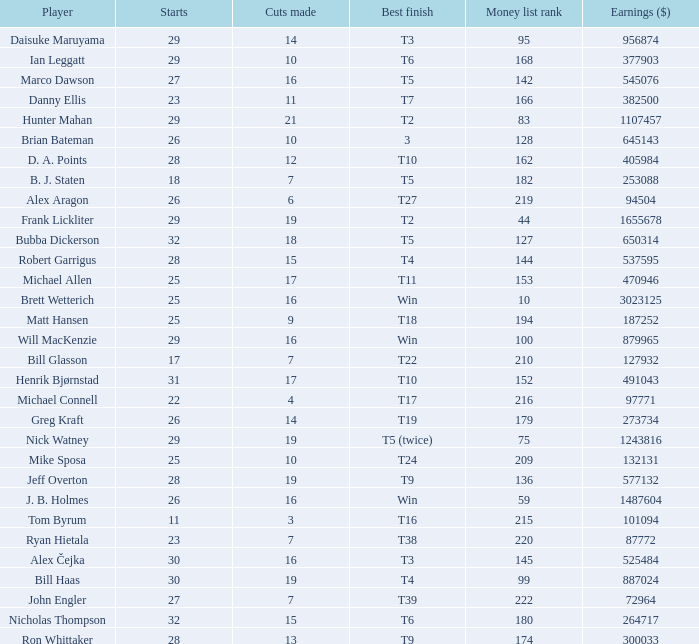What is the minimum number of starts for the players having a best finish of T18? 25.0. Would you be able to parse every entry in this table? {'header': ['Player', 'Starts', 'Cuts made', 'Best finish', 'Money list rank', 'Earnings ($)'], 'rows': [['Daisuke Maruyama', '29', '14', 'T3', '95', '956874'], ['Ian Leggatt', '29', '10', 'T6', '168', '377903'], ['Marco Dawson', '27', '16', 'T5', '142', '545076'], ['Danny Ellis', '23', '11', 'T7', '166', '382500'], ['Hunter Mahan', '29', '21', 'T2', '83', '1107457'], ['Brian Bateman', '26', '10', '3', '128', '645143'], ['D. A. Points', '28', '12', 'T10', '162', '405984'], ['B. J. Staten', '18', '7', 'T5', '182', '253088'], ['Alex Aragon', '26', '6', 'T27', '219', '94504'], ['Frank Lickliter', '29', '19', 'T2', '44', '1655678'], ['Bubba Dickerson', '32', '18', 'T5', '127', '650314'], ['Robert Garrigus', '28', '15', 'T4', '144', '537595'], ['Michael Allen', '25', '17', 'T11', '153', '470946'], ['Brett Wetterich', '25', '16', 'Win', '10', '3023125'], ['Matt Hansen', '25', '9', 'T18', '194', '187252'], ['Will MacKenzie', '29', '16', 'Win', '100', '879965'], ['Bill Glasson', '17', '7', 'T22', '210', '127932'], ['Henrik Bjørnstad', '31', '17', 'T10', '152', '491043'], ['Michael Connell', '22', '4', 'T17', '216', '97771'], ['Greg Kraft', '26', '14', 'T19', '179', '273734'], ['Nick Watney', '29', '19', 'T5 (twice)', '75', '1243816'], ['Mike Sposa', '25', '10', 'T24', '209', '132131'], ['Jeff Overton', '28', '19', 'T9', '136', '577132'], ['J. B. Holmes', '26', '16', 'Win', '59', '1487604'], ['Tom Byrum', '11', '3', 'T16', '215', '101094'], ['Ryan Hietala', '23', '7', 'T38', '220', '87772'], ['Alex Čejka', '30', '16', 'T3', '145', '525484'], ['Bill Haas', '30', '19', 'T4', '99', '887024'], ['John Engler', '27', '7', 'T39', '222', '72964'], ['Nicholas Thompson', '32', '15', 'T6', '180', '264717'], ['Ron Whittaker', '28', '13', 'T9', '174', '300033']]} 